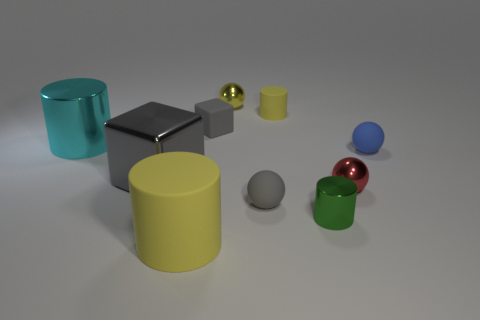Subtract all large shiny cylinders. How many cylinders are left? 3 Subtract all red balls. How many yellow cylinders are left? 2 Subtract all gray balls. How many balls are left? 3 Subtract all brown cylinders. Subtract all gray spheres. How many cylinders are left? 4 Subtract 0 blue cylinders. How many objects are left? 10 Subtract all balls. How many objects are left? 6 Subtract all red metal objects. Subtract all metallic cylinders. How many objects are left? 7 Add 7 large gray things. How many large gray things are left? 8 Add 4 blue things. How many blue things exist? 5 